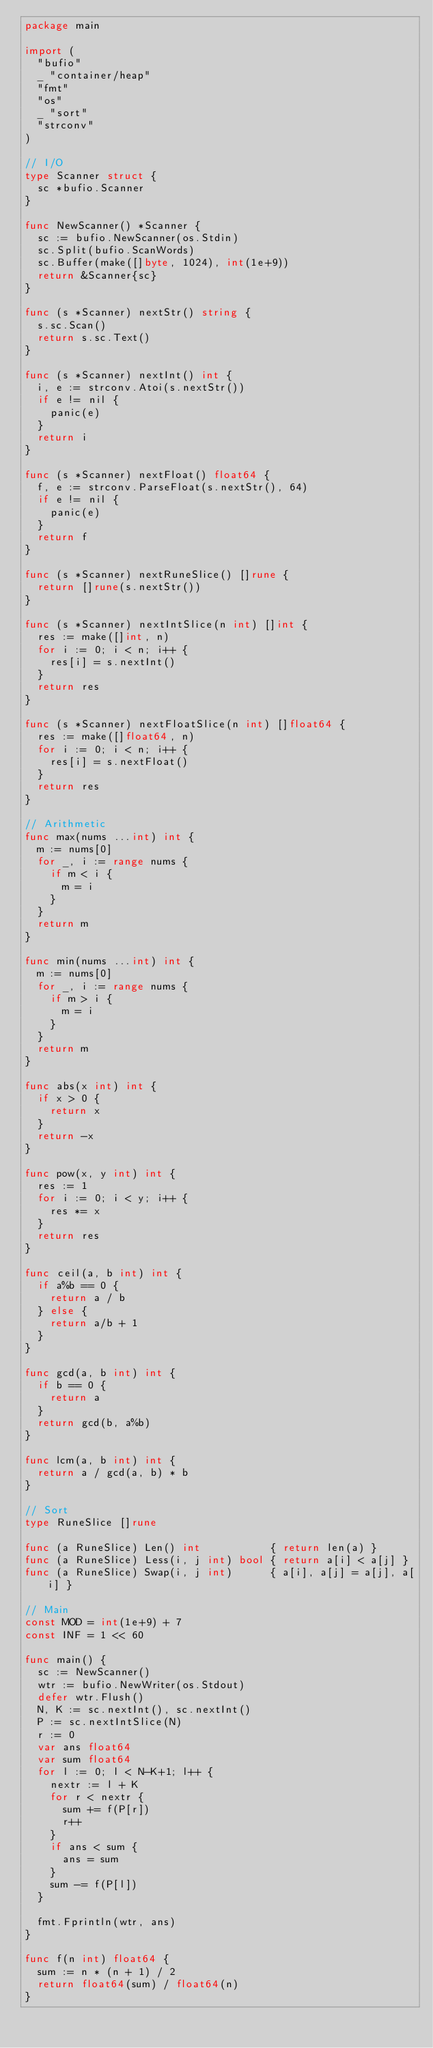<code> <loc_0><loc_0><loc_500><loc_500><_Go_>package main

import (
	"bufio"
	_ "container/heap"
	"fmt"
	"os"
	_ "sort"
	"strconv"
)

// I/O
type Scanner struct {
	sc *bufio.Scanner
}

func NewScanner() *Scanner {
	sc := bufio.NewScanner(os.Stdin)
	sc.Split(bufio.ScanWords)
	sc.Buffer(make([]byte, 1024), int(1e+9))
	return &Scanner{sc}
}

func (s *Scanner) nextStr() string {
	s.sc.Scan()
	return s.sc.Text()
}

func (s *Scanner) nextInt() int {
	i, e := strconv.Atoi(s.nextStr())
	if e != nil {
		panic(e)
	}
	return i
}

func (s *Scanner) nextFloat() float64 {
	f, e := strconv.ParseFloat(s.nextStr(), 64)
	if e != nil {
		panic(e)
	}
	return f
}

func (s *Scanner) nextRuneSlice() []rune {
	return []rune(s.nextStr())
}

func (s *Scanner) nextIntSlice(n int) []int {
	res := make([]int, n)
	for i := 0; i < n; i++ {
		res[i] = s.nextInt()
	}
	return res
}

func (s *Scanner) nextFloatSlice(n int) []float64 {
	res := make([]float64, n)
	for i := 0; i < n; i++ {
		res[i] = s.nextFloat()
	}
	return res
}

// Arithmetic
func max(nums ...int) int {
	m := nums[0]
	for _, i := range nums {
		if m < i {
			m = i
		}
	}
	return m
}

func min(nums ...int) int {
	m := nums[0]
	for _, i := range nums {
		if m > i {
			m = i
		}
	}
	return m
}

func abs(x int) int {
	if x > 0 {
		return x
	}
	return -x
}

func pow(x, y int) int {
	res := 1
	for i := 0; i < y; i++ {
		res *= x
	}
	return res
}

func ceil(a, b int) int {
	if a%b == 0 {
		return a / b
	} else {
		return a/b + 1
	}
}

func gcd(a, b int) int {
	if b == 0 {
		return a
	}
	return gcd(b, a%b)
}

func lcm(a, b int) int {
	return a / gcd(a, b) * b
}

// Sort
type RuneSlice []rune

func (a RuneSlice) Len() int           { return len(a) }
func (a RuneSlice) Less(i, j int) bool { return a[i] < a[j] }
func (a RuneSlice) Swap(i, j int)      { a[i], a[j] = a[j], a[i] }

// Main
const MOD = int(1e+9) + 7
const INF = 1 << 60

func main() {
	sc := NewScanner()
	wtr := bufio.NewWriter(os.Stdout)
	defer wtr.Flush()
	N, K := sc.nextInt(), sc.nextInt()
	P := sc.nextIntSlice(N)
	r := 0
	var ans float64
	var sum float64
	for l := 0; l < N-K+1; l++ {
		nextr := l + K
		for r < nextr {
			sum += f(P[r])
			r++
		}
		if ans < sum {
			ans = sum
		}
		sum -= f(P[l])
	}

	fmt.Fprintln(wtr, ans)
}

func f(n int) float64 {
	sum := n * (n + 1) / 2
	return float64(sum) / float64(n)
}
</code> 